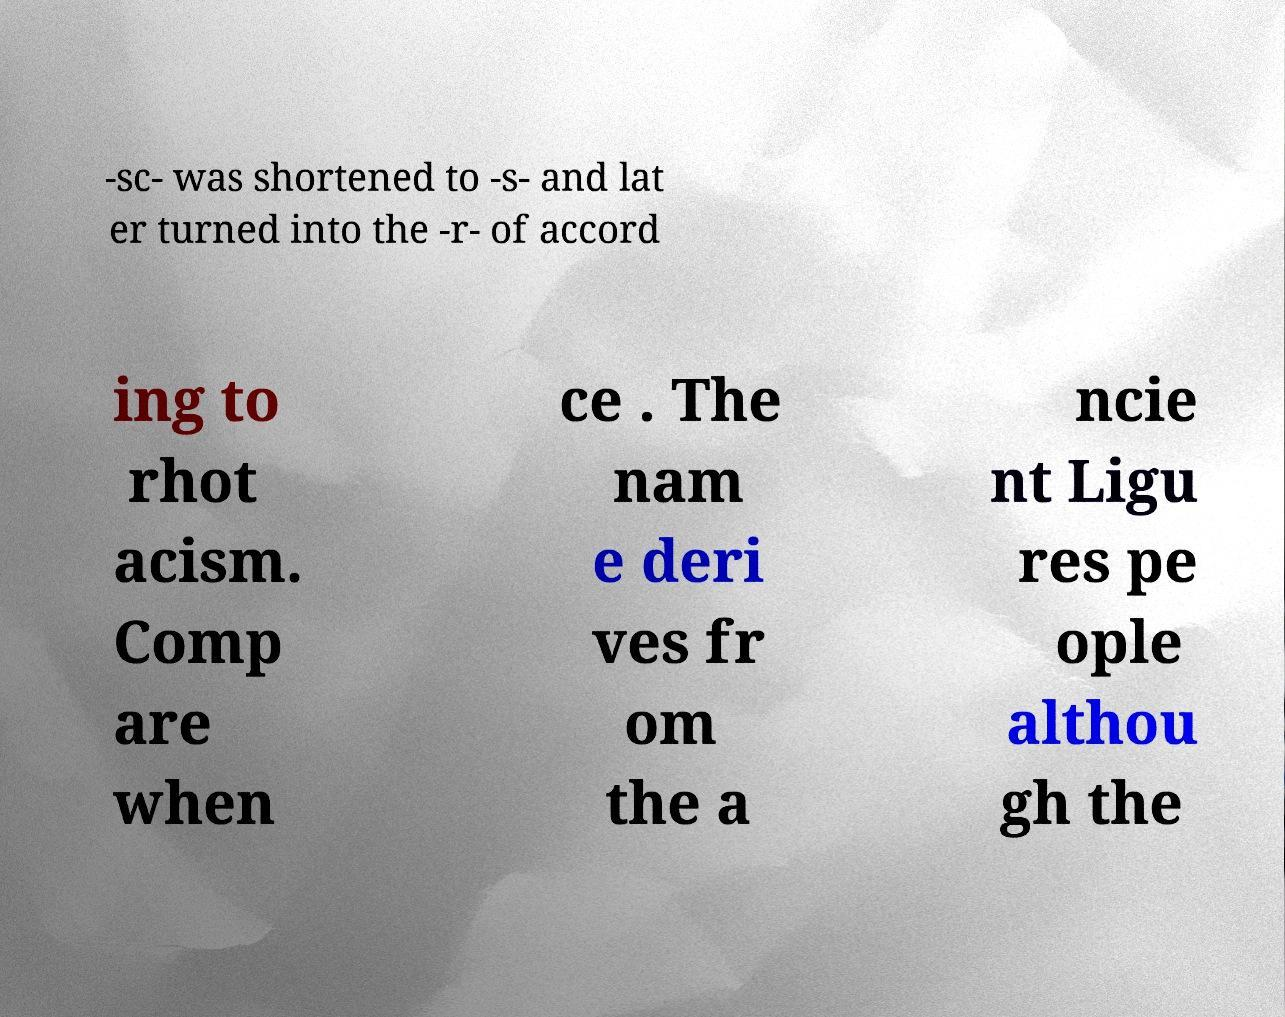Please read and relay the text visible in this image. What does it say? -sc- was shortened to -s- and lat er turned into the -r- of accord ing to rhot acism. Comp are when ce . The nam e deri ves fr om the a ncie nt Ligu res pe ople althou gh the 